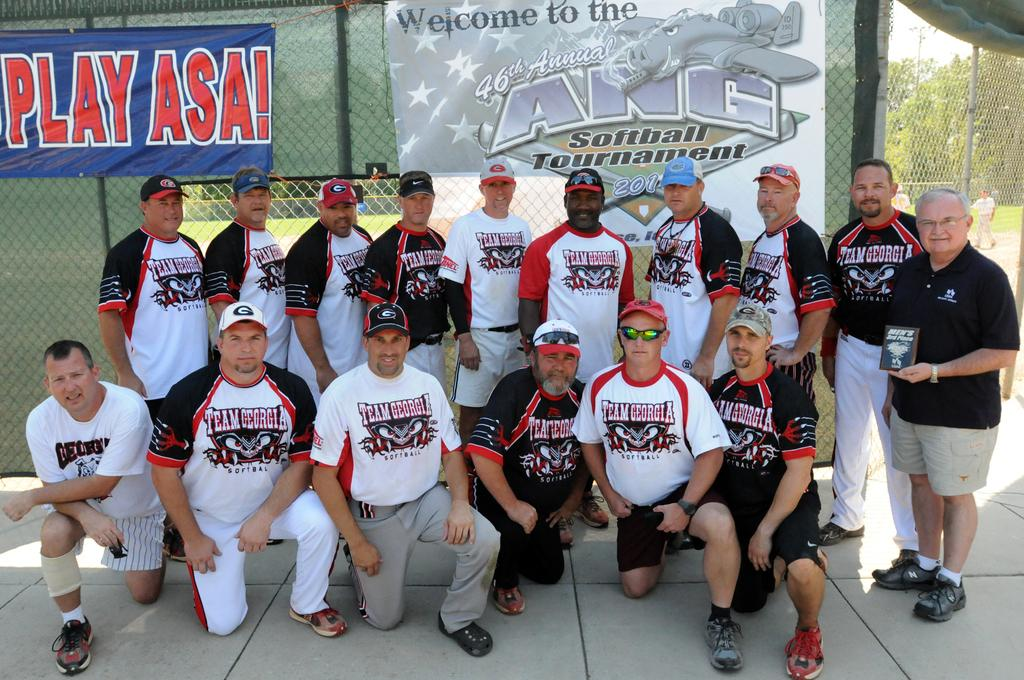<image>
Render a clear and concise summary of the photo. a sign that says play asa on it 